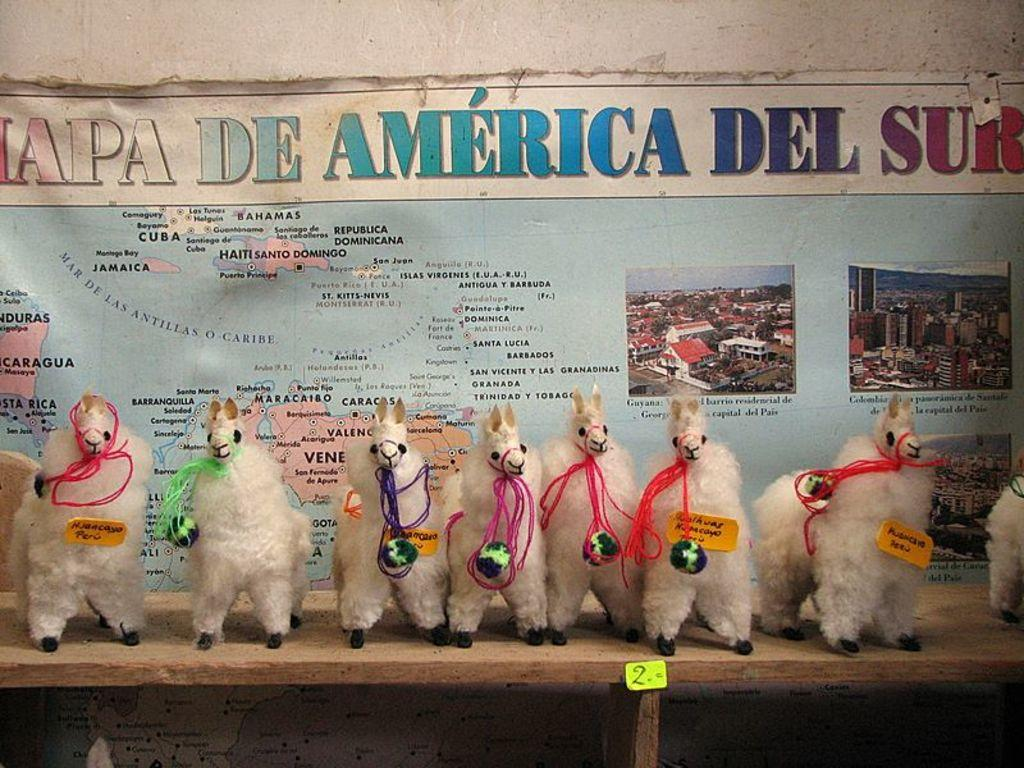What type of toys are visible in the image? There are llama toys in the image. Where are the llama toys located? The llama toys are on a shelf. What is hanging on the wall behind the shelf? There is a map behind the shelf on the wall. What type of ring is visible on the bed in the image? There is no bed or ring present in the image; it features llama toys on a shelf with a map on the wall behind it. 